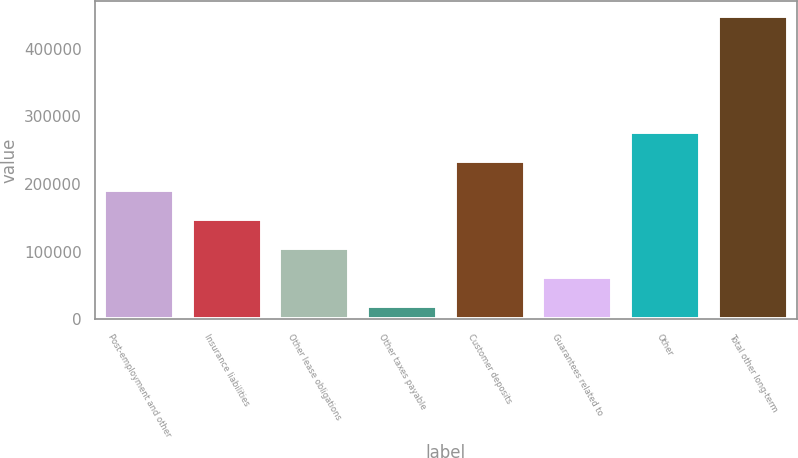Convert chart to OTSL. <chart><loc_0><loc_0><loc_500><loc_500><bar_chart><fcel>Post-employment and other<fcel>Insurance liabilities<fcel>Other lease obligations<fcel>Other taxes payable<fcel>Customer deposits<fcel>Guarantees related to<fcel>Other<fcel>Total other long-term<nl><fcel>190468<fcel>147588<fcel>104707<fcel>18947<fcel>233348<fcel>61827.2<fcel>276228<fcel>447749<nl></chart> 